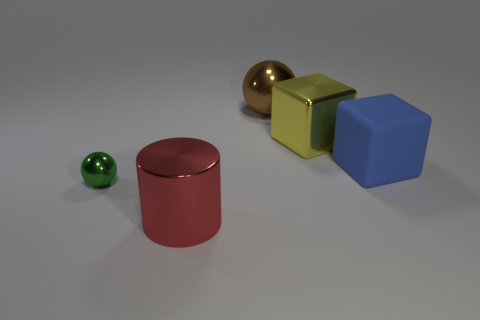Add 2 small red shiny spheres. How many objects exist? 7 Subtract all blocks. How many objects are left? 3 Add 3 large metal cylinders. How many large metal cylinders exist? 4 Subtract 1 green balls. How many objects are left? 4 Subtract all green objects. Subtract all red cylinders. How many objects are left? 3 Add 4 tiny metallic things. How many tiny metallic things are left? 5 